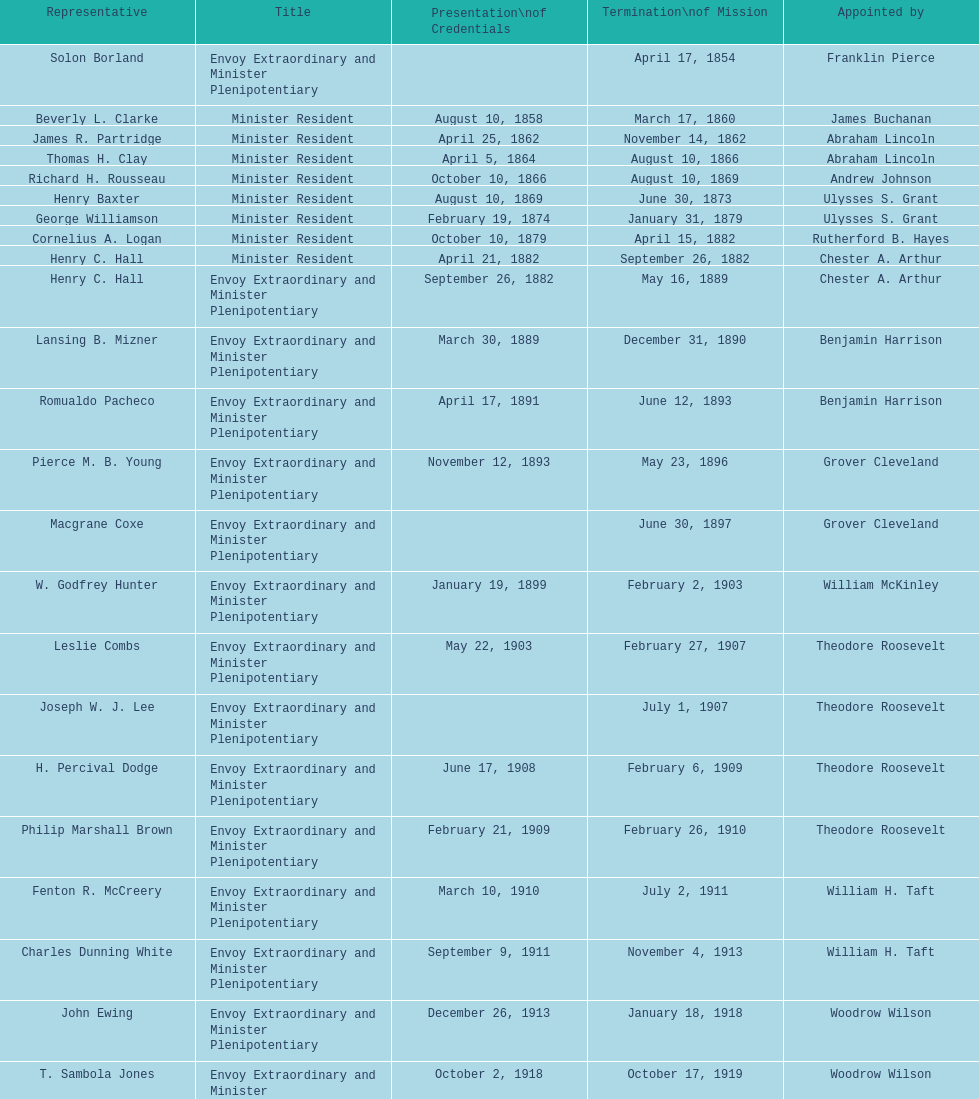Which minister resident had the shortest appointment? Henry C. Hall. 